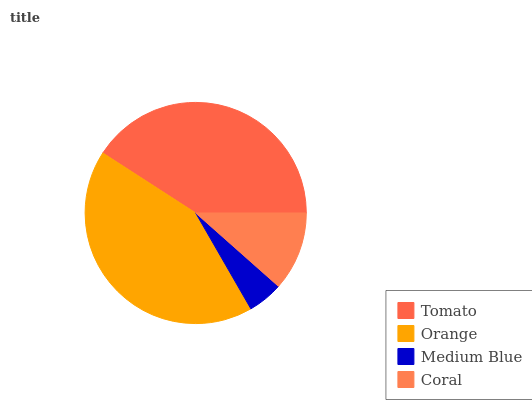Is Medium Blue the minimum?
Answer yes or no. Yes. Is Orange the maximum?
Answer yes or no. Yes. Is Orange the minimum?
Answer yes or no. No. Is Medium Blue the maximum?
Answer yes or no. No. Is Orange greater than Medium Blue?
Answer yes or no. Yes. Is Medium Blue less than Orange?
Answer yes or no. Yes. Is Medium Blue greater than Orange?
Answer yes or no. No. Is Orange less than Medium Blue?
Answer yes or no. No. Is Tomato the high median?
Answer yes or no. Yes. Is Coral the low median?
Answer yes or no. Yes. Is Orange the high median?
Answer yes or no. No. Is Medium Blue the low median?
Answer yes or no. No. 